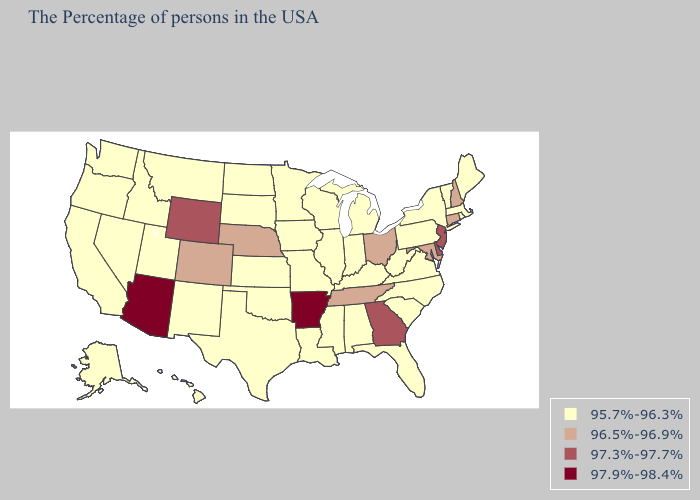How many symbols are there in the legend?
Keep it brief. 4. Does New Jersey have the highest value in the Northeast?
Give a very brief answer. Yes. What is the highest value in the West ?
Quick response, please. 97.9%-98.4%. Does Arizona have the highest value in the USA?
Quick response, please. Yes. What is the highest value in the West ?
Be succinct. 97.9%-98.4%. Among the states that border North Dakota , which have the highest value?
Quick response, please. Minnesota, South Dakota, Montana. What is the lowest value in the USA?
Write a very short answer. 95.7%-96.3%. Among the states that border Nevada , which have the lowest value?
Quick response, please. Utah, Idaho, California, Oregon. Name the states that have a value in the range 96.5%-96.9%?
Answer briefly. New Hampshire, Connecticut, Maryland, Ohio, Tennessee, Nebraska, Colorado. Name the states that have a value in the range 96.5%-96.9%?
Quick response, please. New Hampshire, Connecticut, Maryland, Ohio, Tennessee, Nebraska, Colorado. What is the value of Massachusetts?
Short answer required. 95.7%-96.3%. Which states hav the highest value in the South?
Short answer required. Arkansas. What is the highest value in the USA?
Quick response, please. 97.9%-98.4%. What is the lowest value in the USA?
Answer briefly. 95.7%-96.3%. 